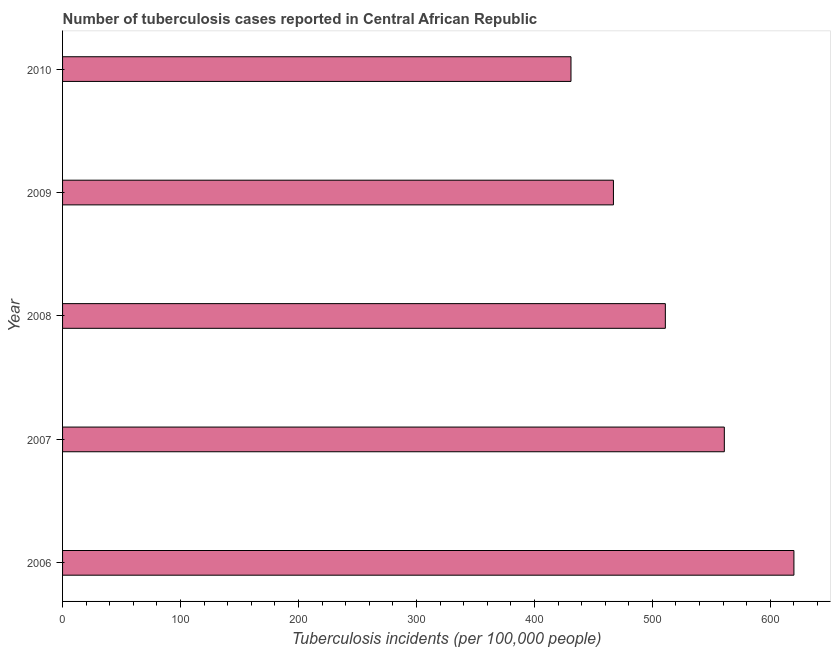Does the graph contain any zero values?
Ensure brevity in your answer.  No. Does the graph contain grids?
Ensure brevity in your answer.  No. What is the title of the graph?
Offer a very short reply. Number of tuberculosis cases reported in Central African Republic. What is the label or title of the X-axis?
Offer a very short reply. Tuberculosis incidents (per 100,0 people). What is the label or title of the Y-axis?
Make the answer very short. Year. What is the number of tuberculosis incidents in 2007?
Your response must be concise. 561. Across all years, what is the maximum number of tuberculosis incidents?
Offer a terse response. 620. Across all years, what is the minimum number of tuberculosis incidents?
Make the answer very short. 431. What is the sum of the number of tuberculosis incidents?
Keep it short and to the point. 2590. What is the difference between the number of tuberculosis incidents in 2007 and 2010?
Your answer should be compact. 130. What is the average number of tuberculosis incidents per year?
Keep it short and to the point. 518. What is the median number of tuberculosis incidents?
Ensure brevity in your answer.  511. Do a majority of the years between 2009 and 2007 (inclusive) have number of tuberculosis incidents greater than 600 ?
Provide a succinct answer. Yes. What is the ratio of the number of tuberculosis incidents in 2006 to that in 2009?
Your response must be concise. 1.33. Is the difference between the number of tuberculosis incidents in 2006 and 2010 greater than the difference between any two years?
Ensure brevity in your answer.  Yes. Is the sum of the number of tuberculosis incidents in 2008 and 2009 greater than the maximum number of tuberculosis incidents across all years?
Offer a very short reply. Yes. What is the difference between the highest and the lowest number of tuberculosis incidents?
Provide a short and direct response. 189. How many bars are there?
Your answer should be compact. 5. Are all the bars in the graph horizontal?
Give a very brief answer. Yes. How many years are there in the graph?
Your answer should be very brief. 5. What is the difference between two consecutive major ticks on the X-axis?
Provide a short and direct response. 100. Are the values on the major ticks of X-axis written in scientific E-notation?
Keep it short and to the point. No. What is the Tuberculosis incidents (per 100,000 people) in 2006?
Your answer should be very brief. 620. What is the Tuberculosis incidents (per 100,000 people) of 2007?
Offer a terse response. 561. What is the Tuberculosis incidents (per 100,000 people) in 2008?
Make the answer very short. 511. What is the Tuberculosis incidents (per 100,000 people) of 2009?
Offer a terse response. 467. What is the Tuberculosis incidents (per 100,000 people) of 2010?
Make the answer very short. 431. What is the difference between the Tuberculosis incidents (per 100,000 people) in 2006 and 2008?
Make the answer very short. 109. What is the difference between the Tuberculosis incidents (per 100,000 people) in 2006 and 2009?
Keep it short and to the point. 153. What is the difference between the Tuberculosis incidents (per 100,000 people) in 2006 and 2010?
Your response must be concise. 189. What is the difference between the Tuberculosis incidents (per 100,000 people) in 2007 and 2008?
Your answer should be compact. 50. What is the difference between the Tuberculosis incidents (per 100,000 people) in 2007 and 2009?
Your answer should be compact. 94. What is the difference between the Tuberculosis incidents (per 100,000 people) in 2007 and 2010?
Offer a terse response. 130. What is the difference between the Tuberculosis incidents (per 100,000 people) in 2008 and 2009?
Keep it short and to the point. 44. What is the difference between the Tuberculosis incidents (per 100,000 people) in 2008 and 2010?
Offer a very short reply. 80. What is the ratio of the Tuberculosis incidents (per 100,000 people) in 2006 to that in 2007?
Provide a succinct answer. 1.1. What is the ratio of the Tuberculosis incidents (per 100,000 people) in 2006 to that in 2008?
Give a very brief answer. 1.21. What is the ratio of the Tuberculosis incidents (per 100,000 people) in 2006 to that in 2009?
Your answer should be very brief. 1.33. What is the ratio of the Tuberculosis incidents (per 100,000 people) in 2006 to that in 2010?
Give a very brief answer. 1.44. What is the ratio of the Tuberculosis incidents (per 100,000 people) in 2007 to that in 2008?
Make the answer very short. 1.1. What is the ratio of the Tuberculosis incidents (per 100,000 people) in 2007 to that in 2009?
Offer a terse response. 1.2. What is the ratio of the Tuberculosis incidents (per 100,000 people) in 2007 to that in 2010?
Offer a very short reply. 1.3. What is the ratio of the Tuberculosis incidents (per 100,000 people) in 2008 to that in 2009?
Make the answer very short. 1.09. What is the ratio of the Tuberculosis incidents (per 100,000 people) in 2008 to that in 2010?
Give a very brief answer. 1.19. What is the ratio of the Tuberculosis incidents (per 100,000 people) in 2009 to that in 2010?
Keep it short and to the point. 1.08. 